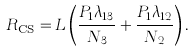<formula> <loc_0><loc_0><loc_500><loc_500>R _ { \text {CS} } = L \left ( \frac { P _ { 1 } \lambda _ { 1 3 } } { N _ { 3 } } + \frac { P _ { 1 } \lambda _ { 1 2 } } { N _ { 2 } } \right ) .</formula> 